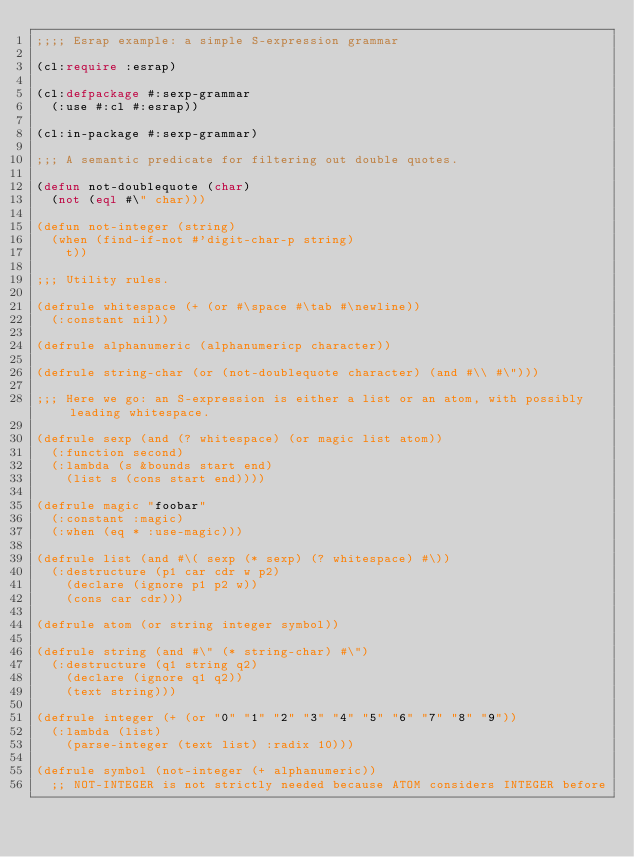<code> <loc_0><loc_0><loc_500><loc_500><_Lisp_>;;;; Esrap example: a simple S-expression grammar

(cl:require :esrap)

(cl:defpackage #:sexp-grammar
  (:use #:cl #:esrap))

(cl:in-package #:sexp-grammar)

;;; A semantic predicate for filtering out double quotes.

(defun not-doublequote (char)
  (not (eql #\" char)))

(defun not-integer (string)
  (when (find-if-not #'digit-char-p string)
    t))

;;; Utility rules.

(defrule whitespace (+ (or #\space #\tab #\newline))
  (:constant nil))

(defrule alphanumeric (alphanumericp character))

(defrule string-char (or (not-doublequote character) (and #\\ #\")))

;;; Here we go: an S-expression is either a list or an atom, with possibly leading whitespace.

(defrule sexp (and (? whitespace) (or magic list atom))
  (:function second)
  (:lambda (s &bounds start end)
    (list s (cons start end))))

(defrule magic "foobar"
  (:constant :magic)
  (:when (eq * :use-magic)))

(defrule list (and #\( sexp (* sexp) (? whitespace) #\))
  (:destructure (p1 car cdr w p2)
    (declare (ignore p1 p2 w))
    (cons car cdr)))

(defrule atom (or string integer symbol))

(defrule string (and #\" (* string-char) #\")
  (:destructure (q1 string q2)
    (declare (ignore q1 q2))
    (text string)))

(defrule integer (+ (or "0" "1" "2" "3" "4" "5" "6" "7" "8" "9"))
  (:lambda (list)
    (parse-integer (text list) :radix 10)))

(defrule symbol (not-integer (+ alphanumeric))
  ;; NOT-INTEGER is not strictly needed because ATOM considers INTEGER before</code> 